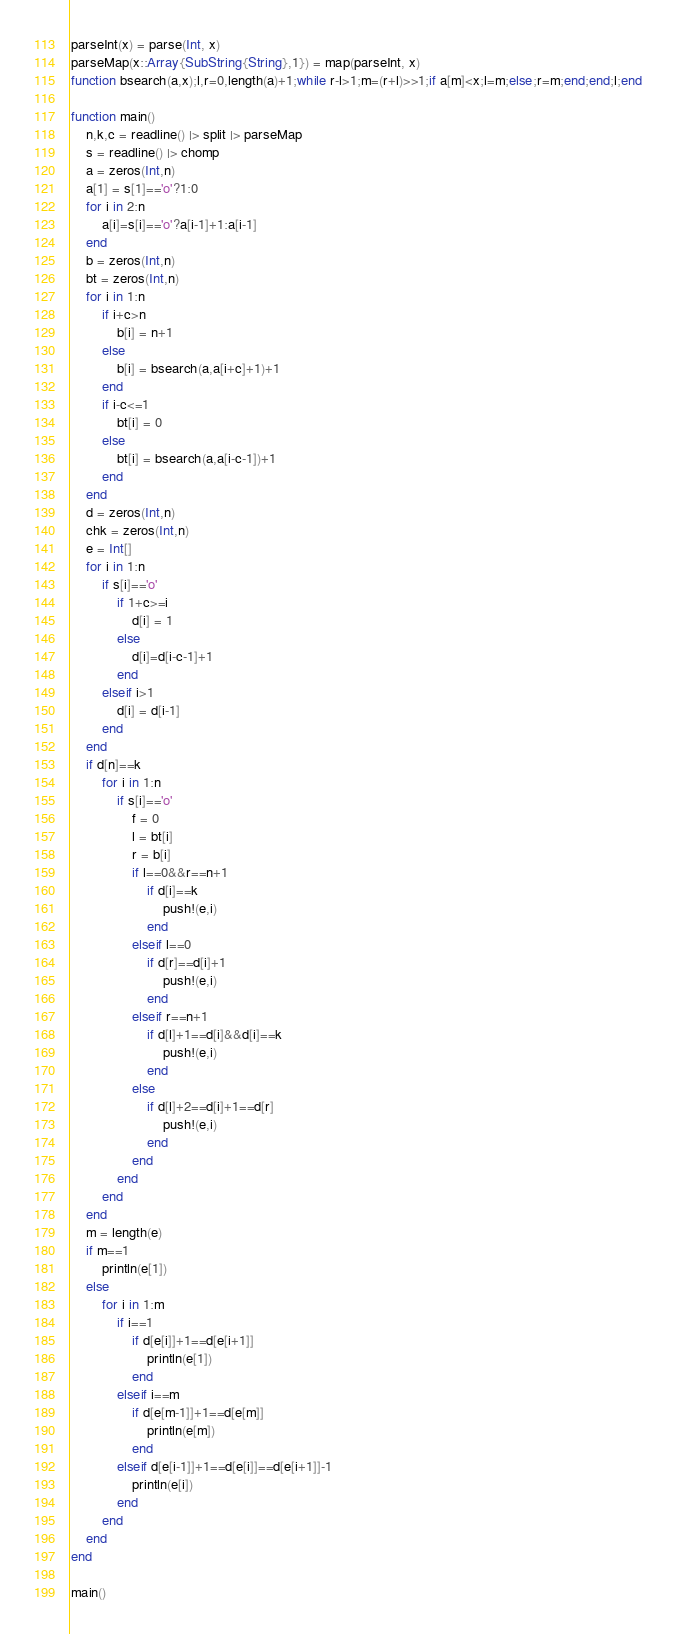<code> <loc_0><loc_0><loc_500><loc_500><_Julia_>parseInt(x) = parse(Int, x)
parseMap(x::Array{SubString{String},1}) = map(parseInt, x)
function bsearch(a,x);l,r=0,length(a)+1;while r-l>1;m=(r+l)>>1;if a[m]<x;l=m;else;r=m;end;end;l;end

function main()
	n,k,c = readline() |> split |> parseMap
	s = readline() |> chomp
	a = zeros(Int,n)
	a[1] = s[1]=='o'?1:0
	for i in 2:n
		a[i]=s[i]=='o'?a[i-1]+1:a[i-1]
	end
	b = zeros(Int,n)
	bt = zeros(Int,n)
	for i in 1:n
		if i+c>n
			b[i] = n+1
		else
			b[i] = bsearch(a,a[i+c]+1)+1
		end
		if i-c<=1
			bt[i] = 0
		else
			bt[i] = bsearch(a,a[i-c-1])+1
		end
	end
	d = zeros(Int,n)
	chk = zeros(Int,n)
	e = Int[]
	for i in 1:n
		if s[i]=='o'
			if 1+c>=i
				d[i] = 1
			else
				d[i]=d[i-c-1]+1
			end
		elseif i>1
			d[i] = d[i-1]
		end
	end
	if d[n]==k
		for i in 1:n
			if s[i]=='o'
				f = 0
				l = bt[i]
				r = b[i]
				if l==0&&r==n+1
					if d[i]==k
						push!(e,i)
					end
				elseif l==0
					if d[r]==d[i]+1
						push!(e,i)
					end
				elseif r==n+1
					if d[l]+1==d[i]&&d[i]==k
						push!(e,i)
					end
				else
					if d[l]+2==d[i]+1==d[r]
						push!(e,i)
					end
				end
			end
		end
	end
	m = length(e)
	if m==1
		println(e[1])
	else
		for i in 1:m
			if i==1
				if d[e[i]]+1==d[e[i+1]]
					println(e[1])
				end
			elseif i==m
				if d[e[m-1]]+1==d[e[m]]
					println(e[m])
				end
			elseif d[e[i-1]]+1==d[e[i]]==d[e[i+1]]-1
				println(e[i])
			end
		end
	end
end

main()</code> 